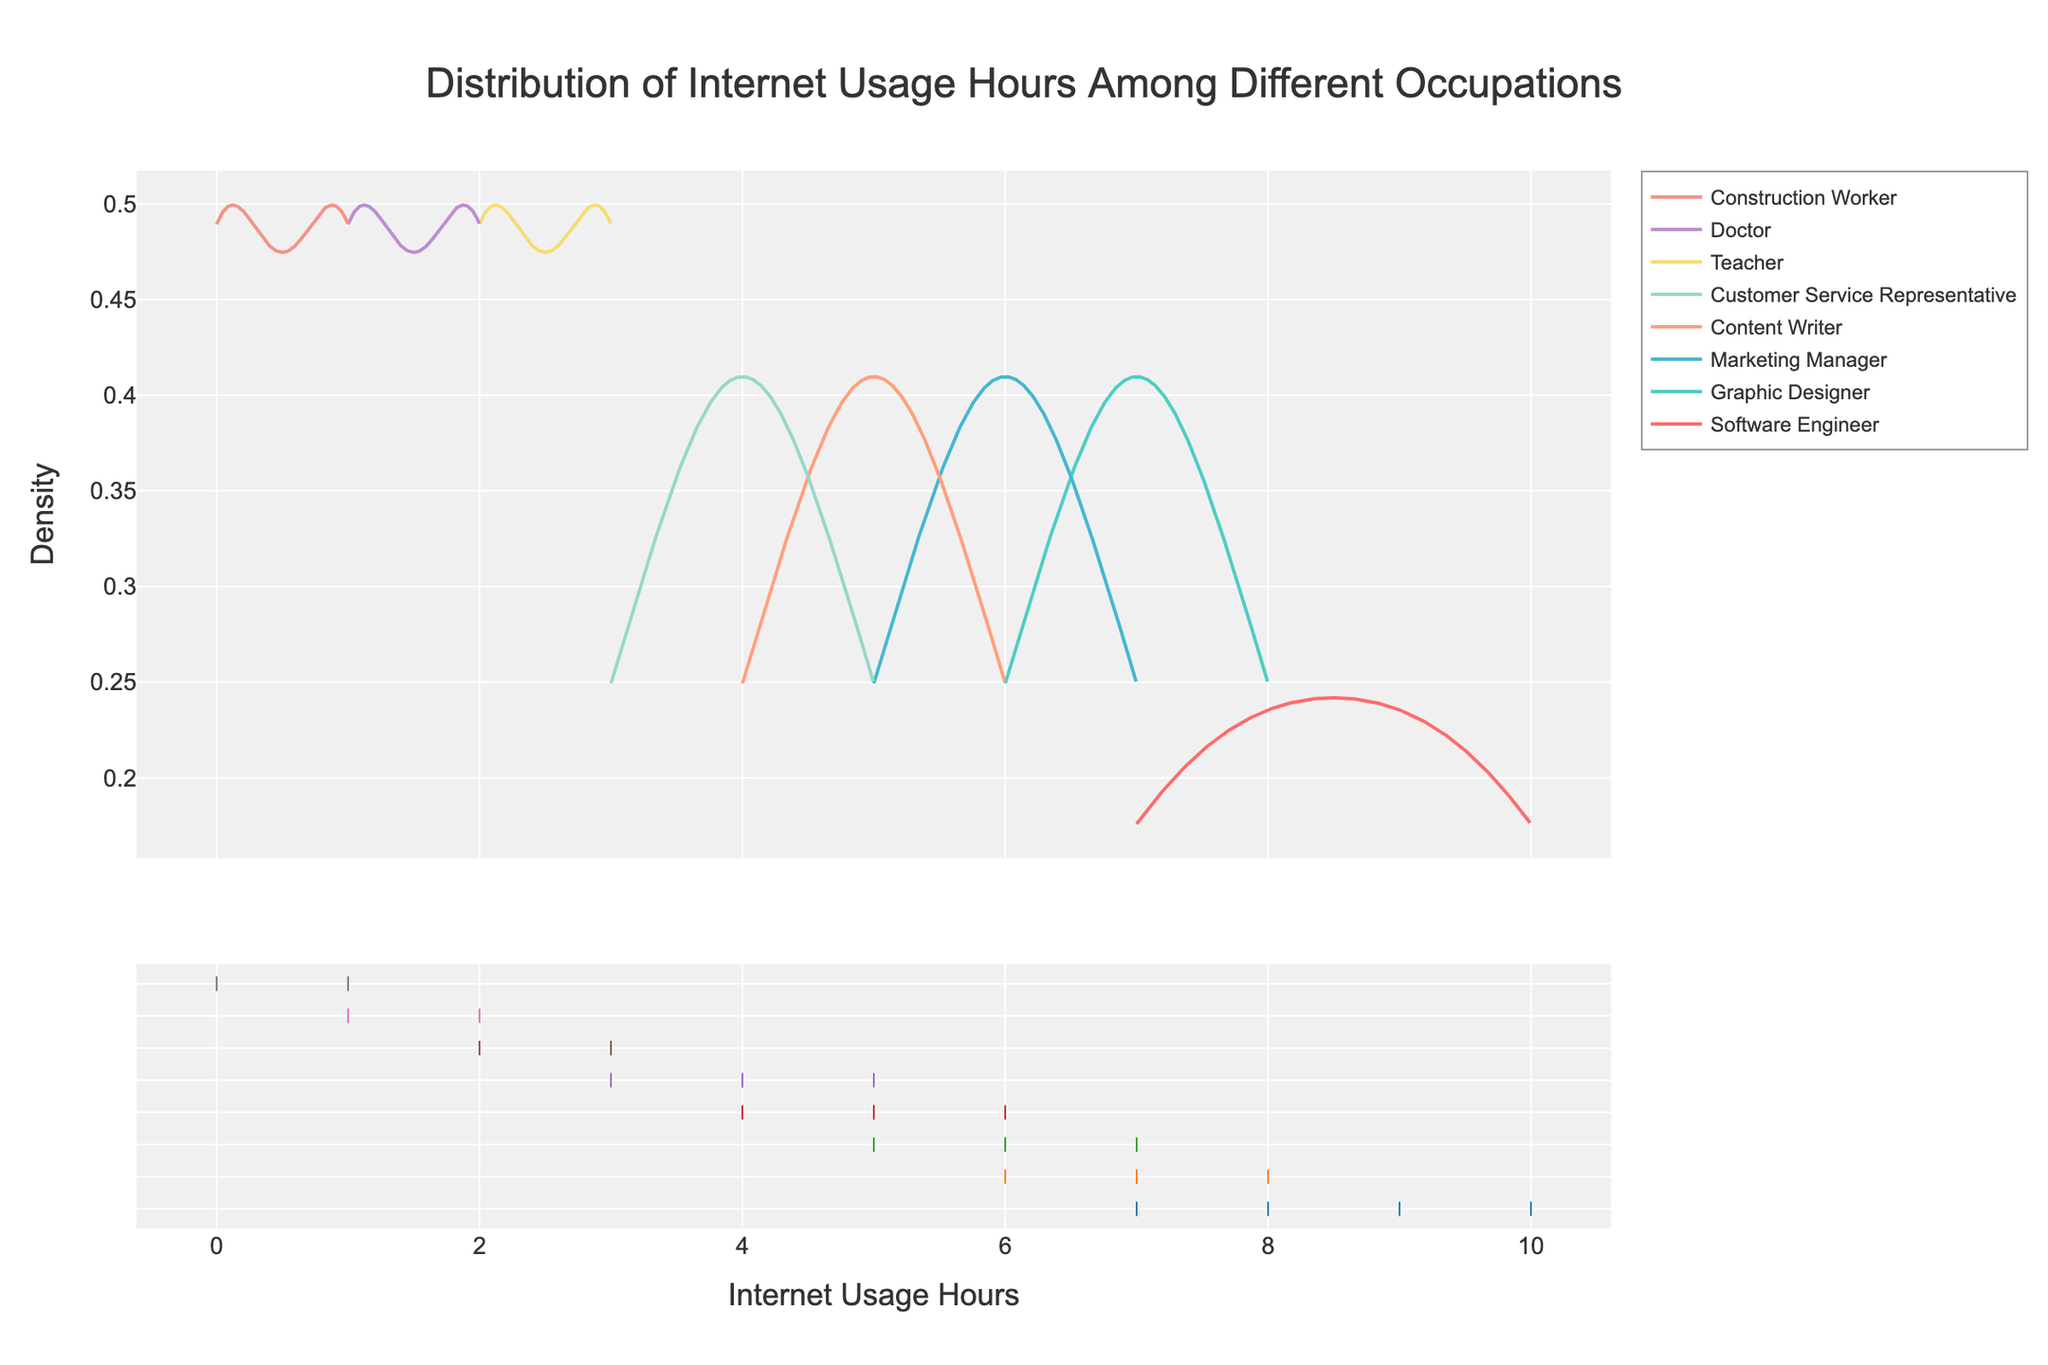What is the title of the figure? The title of the figure is usually placed at the top of the plot. In this case, the title is centered and in a larger font size than the other text elements.
Answer: Distribution of Internet Usage Hours Among Different Occupations What does the x-axis represent in this figure? The x-axis represents the number of hours spent on the internet. This is indicated by the x-axis title, which is 'Internet Usage Hours'.
Answer: Internet Usage Hours What does the y-axis represent in this figure? The y-axis represents the density of the internet usage hours data. This is indicated by the y-axis title, which is 'Density'.
Answer: Density Which occupation has the highest average internet usage hours? By observing the peaks of the density curves, we can see which curve extends furthest to the right. The Software Engineer curve peaks around 9 hours, which is higher compared to other occupations.
Answer: Software Engineer Which occupation has the most diverse range of internet usage hours? To determine diversity, we look for the occupation with the widest spread of the data. The Software Engineer curve extends from about 7 to 10 hours, indicating a diverse range.
Answer: Software Engineer How do the internet usage hours of 'Doctors' compare to 'Teachers'? By comparing the peaks of the density curves, we see that Doctors have a peak around 1-2 hours, while Teachers peak around 2-3 hours, making Teachers use the internet more on average.
Answer: Teachers What is the approximate internet usage range for 'Construction Workers'? The curve for Construction Workers starts around 0 and extends to about 1-1.5 hours, showing their internet usage range.
Answer: 0-1.5 hours Which group has the smallest range of internet usage hours? The occupation with the narrowest spread is 'Doctors', as their curve is tightly clustered around 1-2 hours.
Answer: Doctors What is the median internet usage hours for 'Content Writers'? The median value is roughly where the density curve is highest. For Content Writers, it peaks around 5-6 hours, making the median approximately in this range.
Answer: 5-6 hours Between 'Marketing Managers' and 'Graphic Designers', who uses the internet less on average? By comparing the peaks of their density curves, Marketing Managers peak around 6 hours, whereas Graphic Designers peak around 7 hours, indicating Marketing Managers use less on average.
Answer: Marketing Managers 